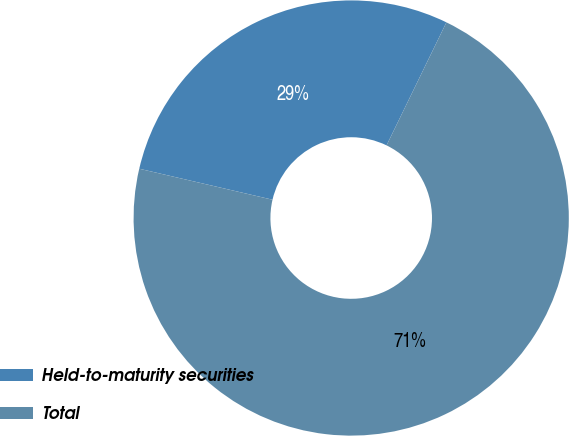Convert chart to OTSL. <chart><loc_0><loc_0><loc_500><loc_500><pie_chart><fcel>Held-to-maturity securities<fcel>Total<nl><fcel>28.57%<fcel>71.43%<nl></chart> 